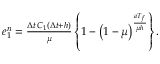Convert formula to latex. <formula><loc_0><loc_0><loc_500><loc_500>\begin{array} { r } { e _ { 1 } ^ { n } = \frac { \Delta t \, C _ { 1 } ( \Delta t + h ) } { \mu } \left \{ 1 - \left ( 1 - \mu \right ) ^ { \frac { a T _ { f } } { \mu h } } \right \} . } \end{array}</formula> 